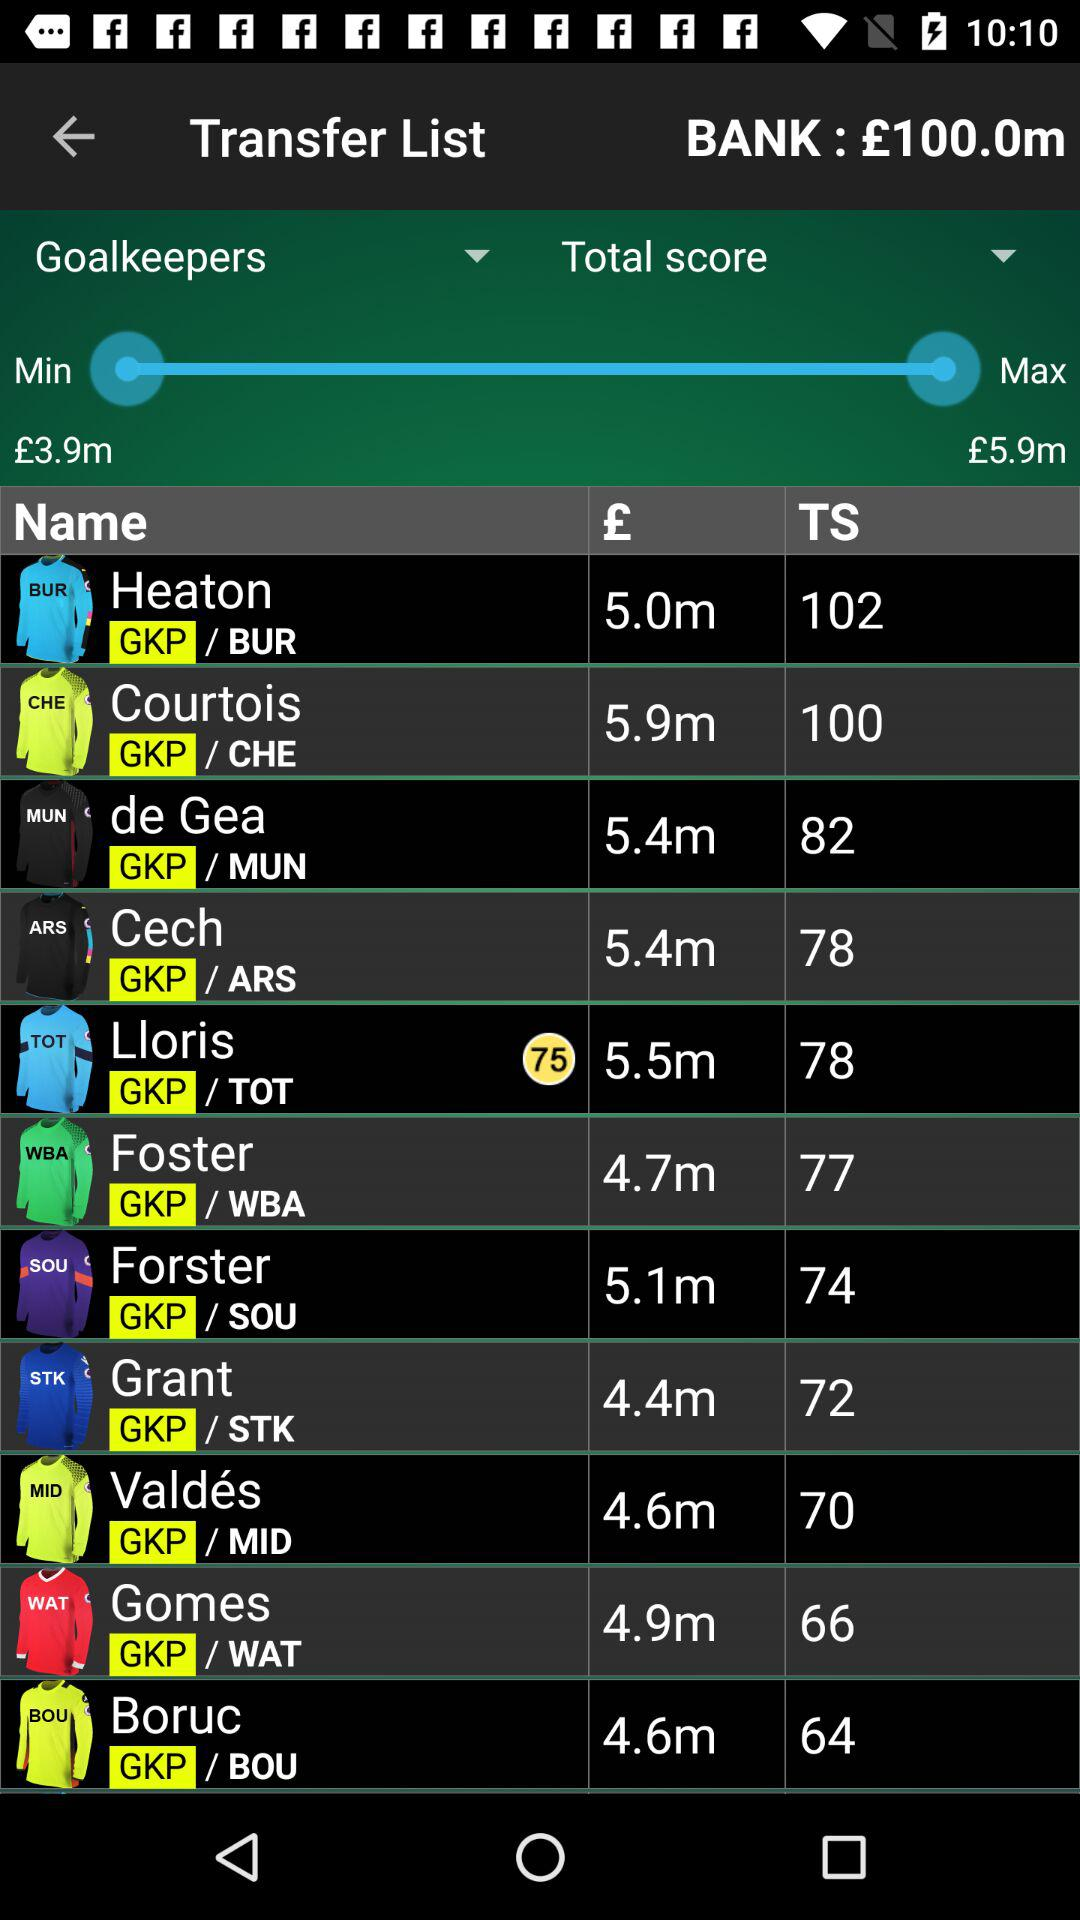What's the minimum amount? The minimum amount is £3.9 million. 